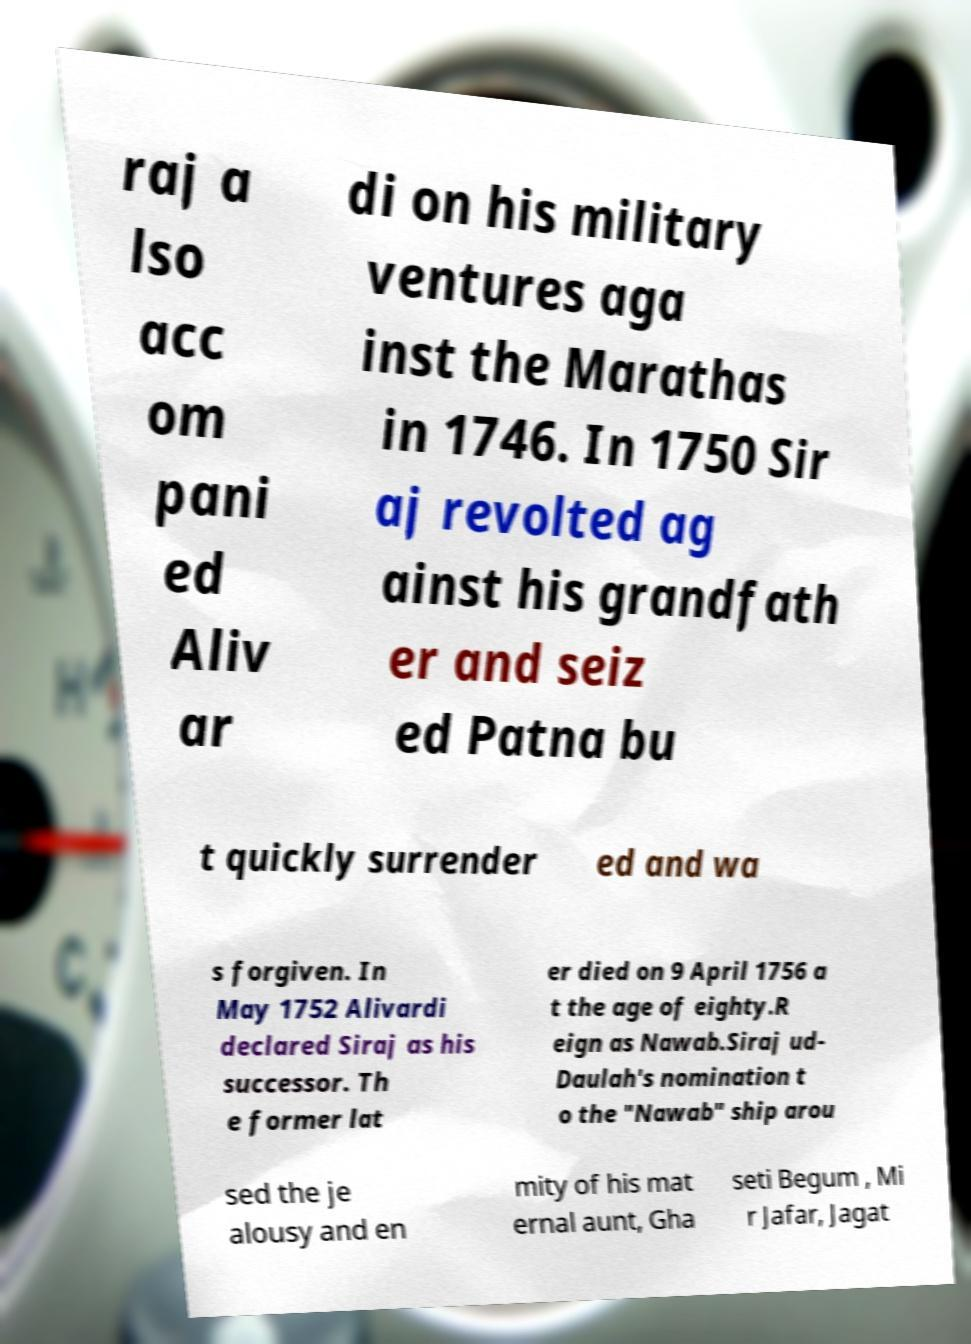Could you assist in decoding the text presented in this image and type it out clearly? raj a lso acc om pani ed Aliv ar di on his military ventures aga inst the Marathas in 1746. In 1750 Sir aj revolted ag ainst his grandfath er and seiz ed Patna bu t quickly surrender ed and wa s forgiven. In May 1752 Alivardi declared Siraj as his successor. Th e former lat er died on 9 April 1756 a t the age of eighty.R eign as Nawab.Siraj ud- Daulah's nomination t o the "Nawab" ship arou sed the je alousy and en mity of his mat ernal aunt, Gha seti Begum , Mi r Jafar, Jagat 